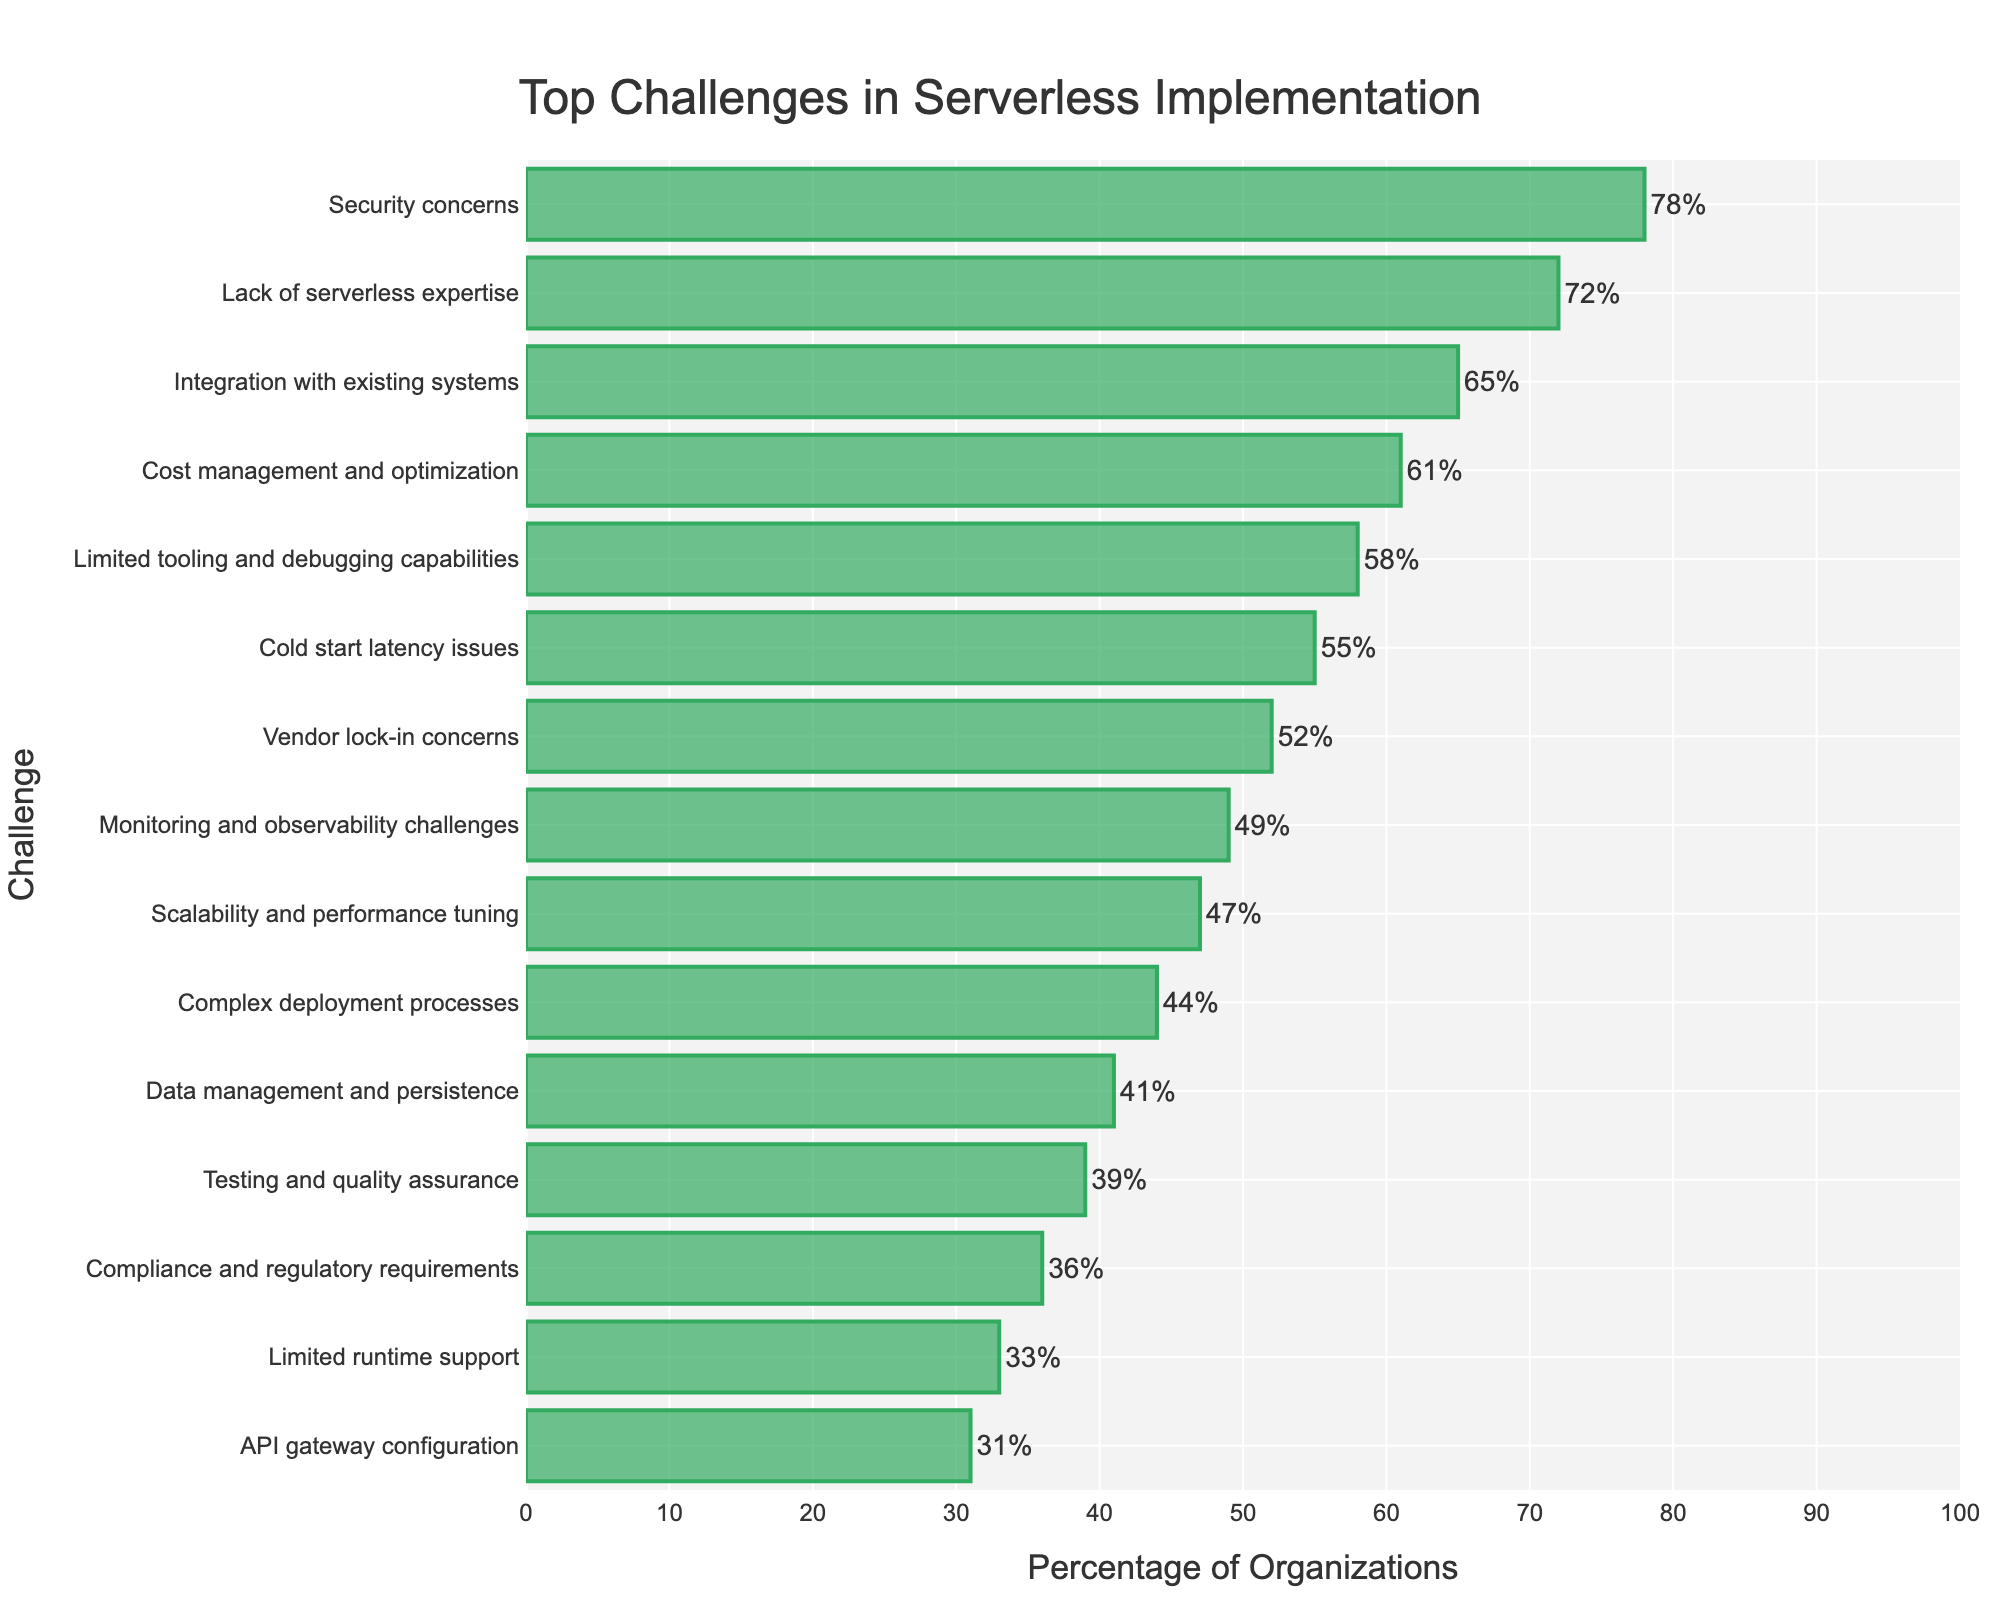Which challenge is reported by the highest percentage of organizations? The bar representing "Security concerns" is the longest and is positioned at the top of the chart. It shows a percentage of 78, which is higher than any other challenge listed.
Answer: Security concerns Which challenge is faced by 41% of organizations? By observing the lengths of the bars and their corresponding labels, the bar for "Data management and persistence" shows a value of 41%.
Answer: Data management and persistence How many challenges are faced by more than 50% of organizations? Count the bars whose percentage values are greater than 50. These are: Security concerns (78), Lack of serverless expertise (72), Integration with existing systems (65), Cost management and optimization (61), Limited tooling and debugging capabilities (58), and Cold start latency issues (55), Vendor lock-in concerns (52). A total of seven bars indicate more than 50%.
Answer: 7 Which challenge is faced by the least percentage of organizations? The shortest bar on the chart has the label "API gateway configuration" and shows a percentage of 31, which is lower than any other percentages listed.
Answer: API gateway configuration What is the difference in percentage between "Cost management and optimization" and "Cold start latency issues"? The bar for "Cost management and optimization" shows 61%, and the bar for "Cold start latency issues" shows 55%. Subtracting the latter from the former results in 6.
Answer: 6% Which two challenges have a difference of 2% in the percentage of organizations facing them? Observing the percentages, "Testing and quality assurance" (39%) and "Compliance and regulatory requirements" (36%) differ by 3%. "Compliance and regulatory requirements" and "Limited runtime support" differ by 3%. The correct pair is "Scalability and performance tuning" (47%) and "Complex deployment processes" (44%), differing by 3. None are exactly 2% apart.
Answer: None What is the average percentage of the bottom five challenges? Sum the percentages of the bottom five challenges: Limited runtime support (33), API gateway configuration (31), Compliance and regulatory requirements (36), Testing and quality assurance (39), Data management and persistence (41). Their sum is 180. Divide by 5 to get the average: 180/5 = 36.
Answer: 36% By how much does the percentage for "Integration with existing systems" exceed the percentage for "Scalability and performance tuning"? The bar for "Integration with existing systems" shows 65%, and the bar for "Scalability and performance tuning" shows 47%. Subtracting 47% from 65% results in an 18% difference.
Answer: 18% 